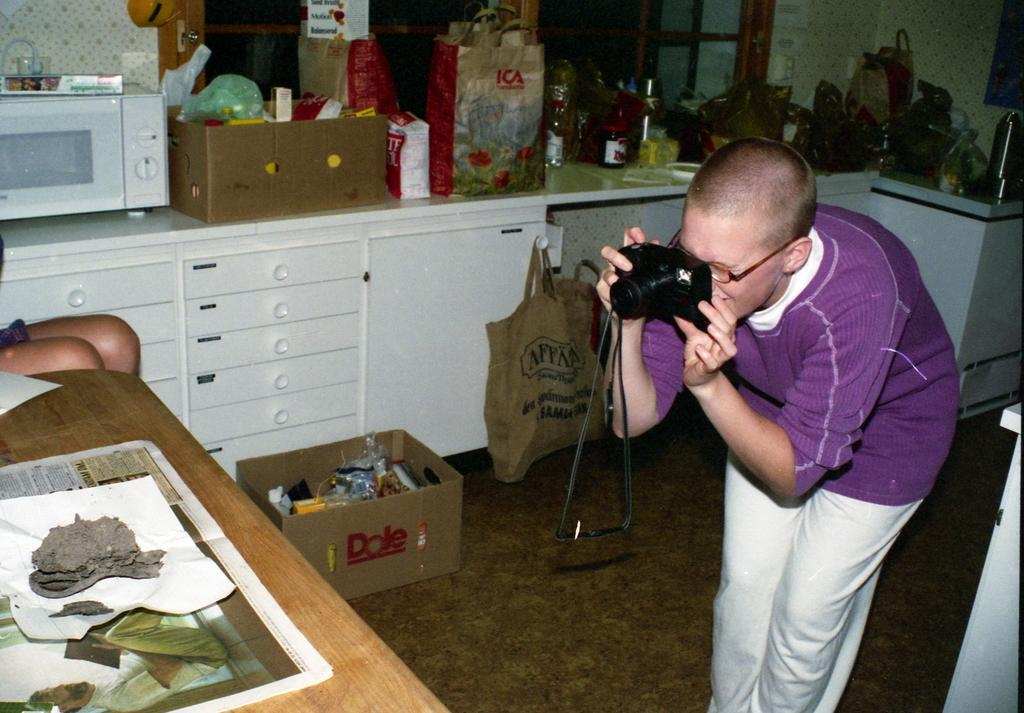<image>
Summarize the visual content of the image. a Dole box is sitting beside the person who is taking a picture of the table. 